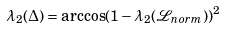Convert formula to latex. <formula><loc_0><loc_0><loc_500><loc_500>\lambda _ { 2 } ( \Delta ) = \arccos ( 1 - \lambda _ { 2 } ( \mathcal { L } _ { n o r m } ) ) ^ { 2 }</formula> 